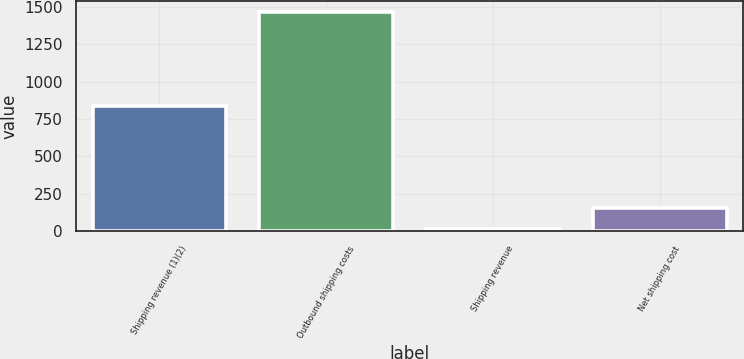Convert chart to OTSL. <chart><loc_0><loc_0><loc_500><loc_500><bar_chart><fcel>Shipping revenue (1)(2)<fcel>Outbound shipping costs<fcel>Shipping revenue<fcel>Net shipping cost<nl><fcel>835<fcel>1465<fcel>13<fcel>158.2<nl></chart> 